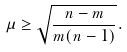<formula> <loc_0><loc_0><loc_500><loc_500>\mu \geq \sqrt { \frac { n - m } { m ( n - 1 ) } } .</formula> 